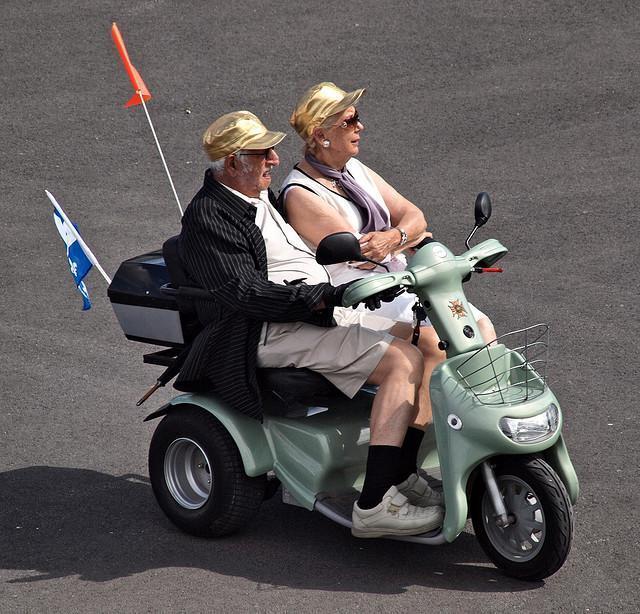How many motorcycles are there?
Give a very brief answer. 1. How many people can you see?
Give a very brief answer. 2. How many cups are on the table?
Give a very brief answer. 0. 